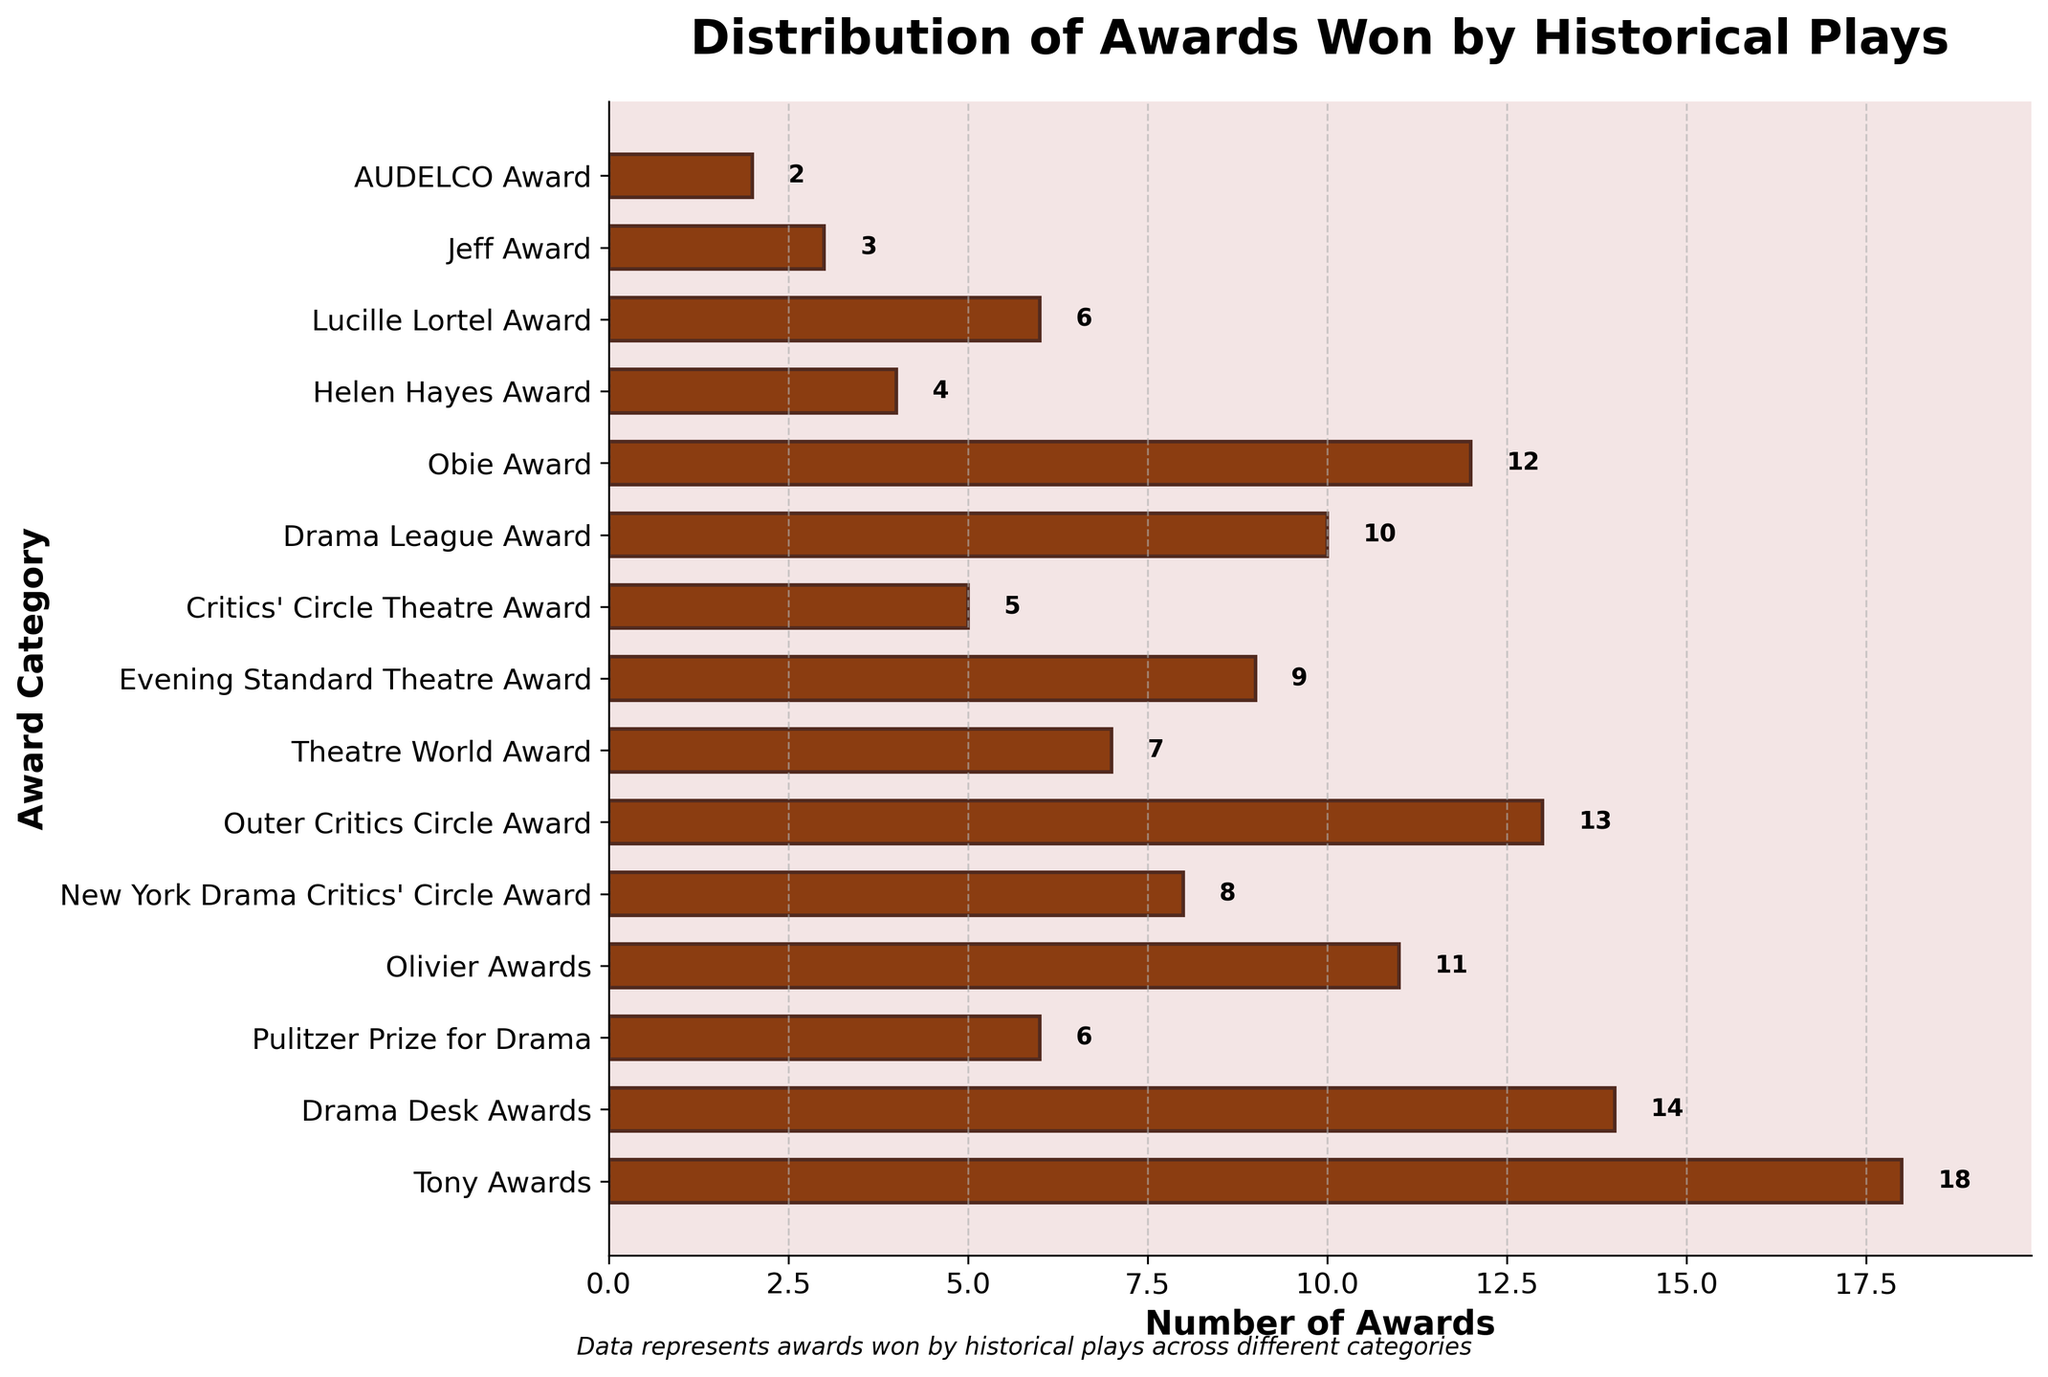What is the category with the highest number of awards? By looking at the top of the horizontal bar chart, the category with the longest bar represents the highest number of awards. The "Tony Awards" bar is the longest.
Answer: Tony Awards Which category has more awards: Drama Desk Awards or Obie Award? Compare the length of the bars for "Drama Desk Awards" and "Obie Award". The Drama Desk Awards bar is longer at 14 awards, whereas the Obie Award bar has 12 awards.
Answer: Drama Desk Awards What is the combined total number of awards for the Pulitzer Prize for Drama and the Olivier Awards? Find the numbers for Pulitzer Prize for Drama (6) and Olivier Awards (11), then sum them up: 6 + 11 = 17.
Answer: 17 Which categories have fewer than 5 awards? Identify the bars with lengths less than 5. The "Helen Hayes Award" (4), "Jeff Award" (3), and "AUDELCO Award" (2) fall into this category.
Answer: Helen Hayes Award, Jeff Award, AUDELCO Award What is the difference in the number of awards between the New York Drama Critics' Circle Award and the Critics' Circle Theatre Award? Find the awards for New York Drama Critics' Circle Award (8) and Critics' Circle Theatre Award (5), then calculate the difference: 8 - 5 = 3.
Answer: 3 How many categories have more than 10 awards? Count the categories with bars indicating values greater than 10. These are "Tony Awards" (18), "Drama Desk Awards" (14), "Olivier Awards" (11), "Outer Critics Circle Award" (13), and "Obie Award" (12), making a total of 5 categories.
Answer: 5 What is the total number of awards for the three categories with the fewest awards? Identify the three smallest bars which are "Jeff Award" (3), "AUDELCO Award" (2), and "Helen Hayes Award" (4). Sum these values: 3 + 2 + 4 = 9.
Answer: 9 Is the number of awards for the Drama League Award greater than or equal to those for the Evening Standard Theatre Award? Compare the lengths of the two bars. The Drama League Award has 10 awards, which is greater than the Evening Standard Theatre Award with 9 awards.
Answer: Yes Which award category has the second highest number of awards? Identify the second longest bar after the "Tony Awards" bar. The "Drama Desk Awards" bar is next at 14 awards.
Answer: Drama Desk Awards 